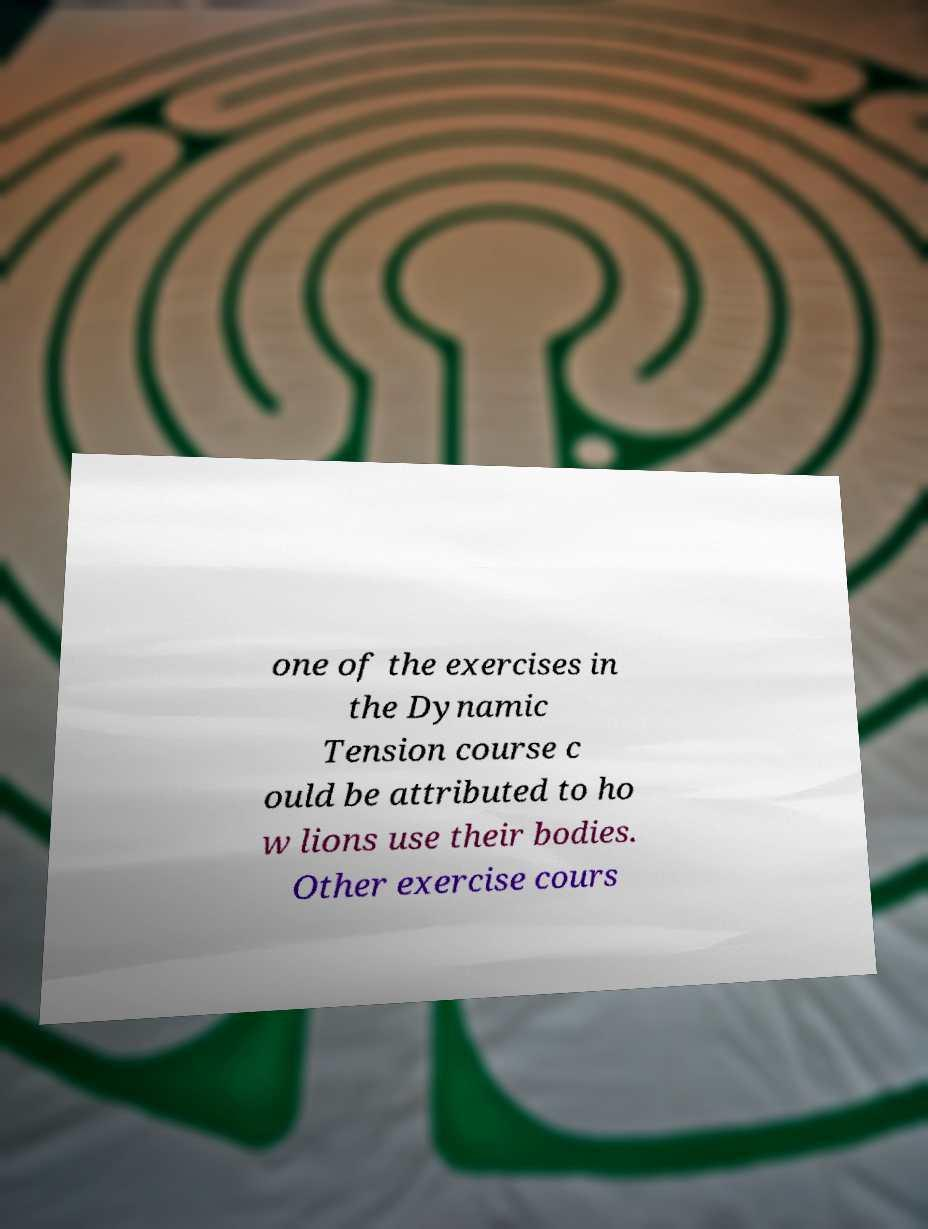What messages or text are displayed in this image? I need them in a readable, typed format. one of the exercises in the Dynamic Tension course c ould be attributed to ho w lions use their bodies. Other exercise cours 